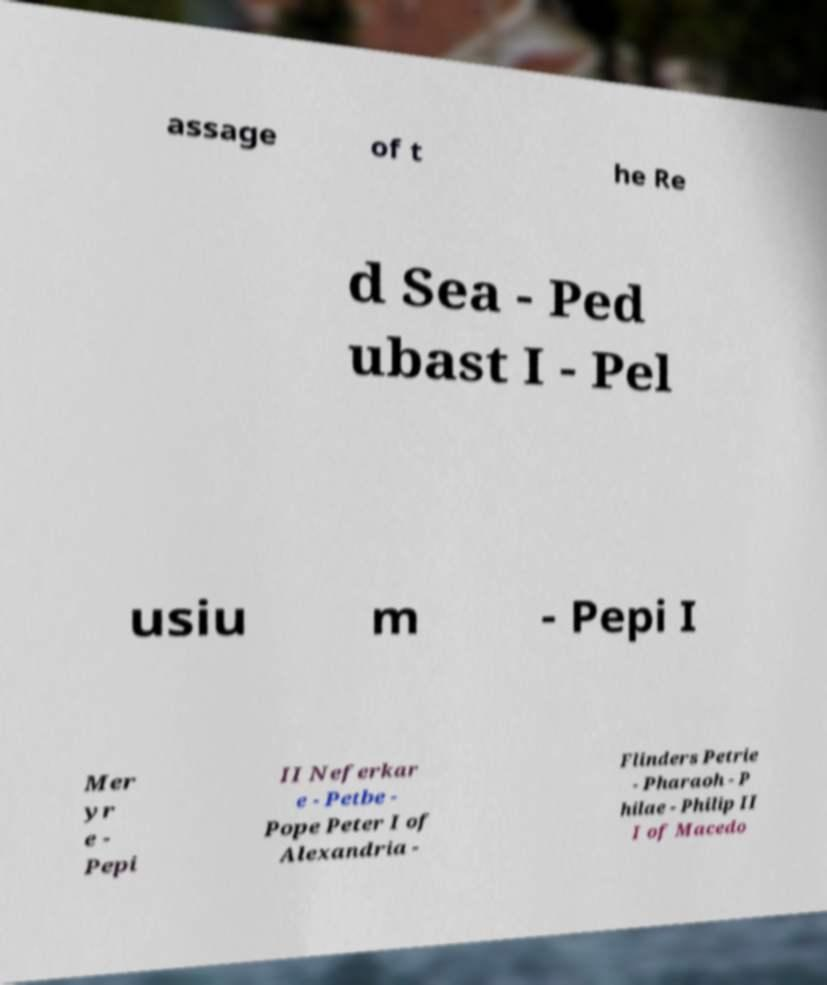Please read and relay the text visible in this image. What does it say? assage of t he Re d Sea - Ped ubast I - Pel usiu m - Pepi I Mer yr e - Pepi II Neferkar e - Petbe - Pope Peter I of Alexandria - Flinders Petrie - Pharaoh - P hilae - Philip II I of Macedo 